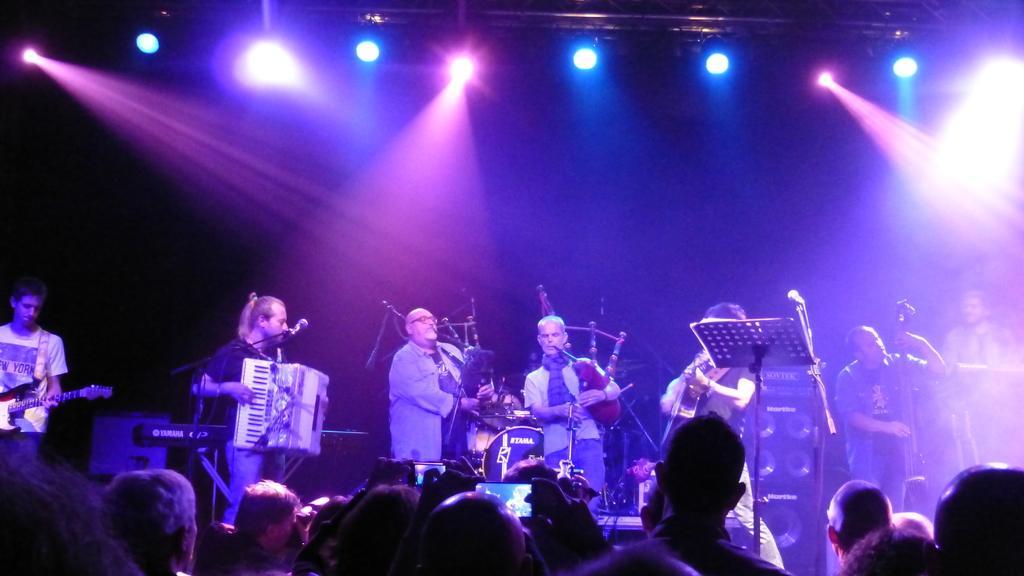Please provide a concise description of this image. there are many people standing and playing musical instruments with a microphone in front of them there are some people standing in front of them. 